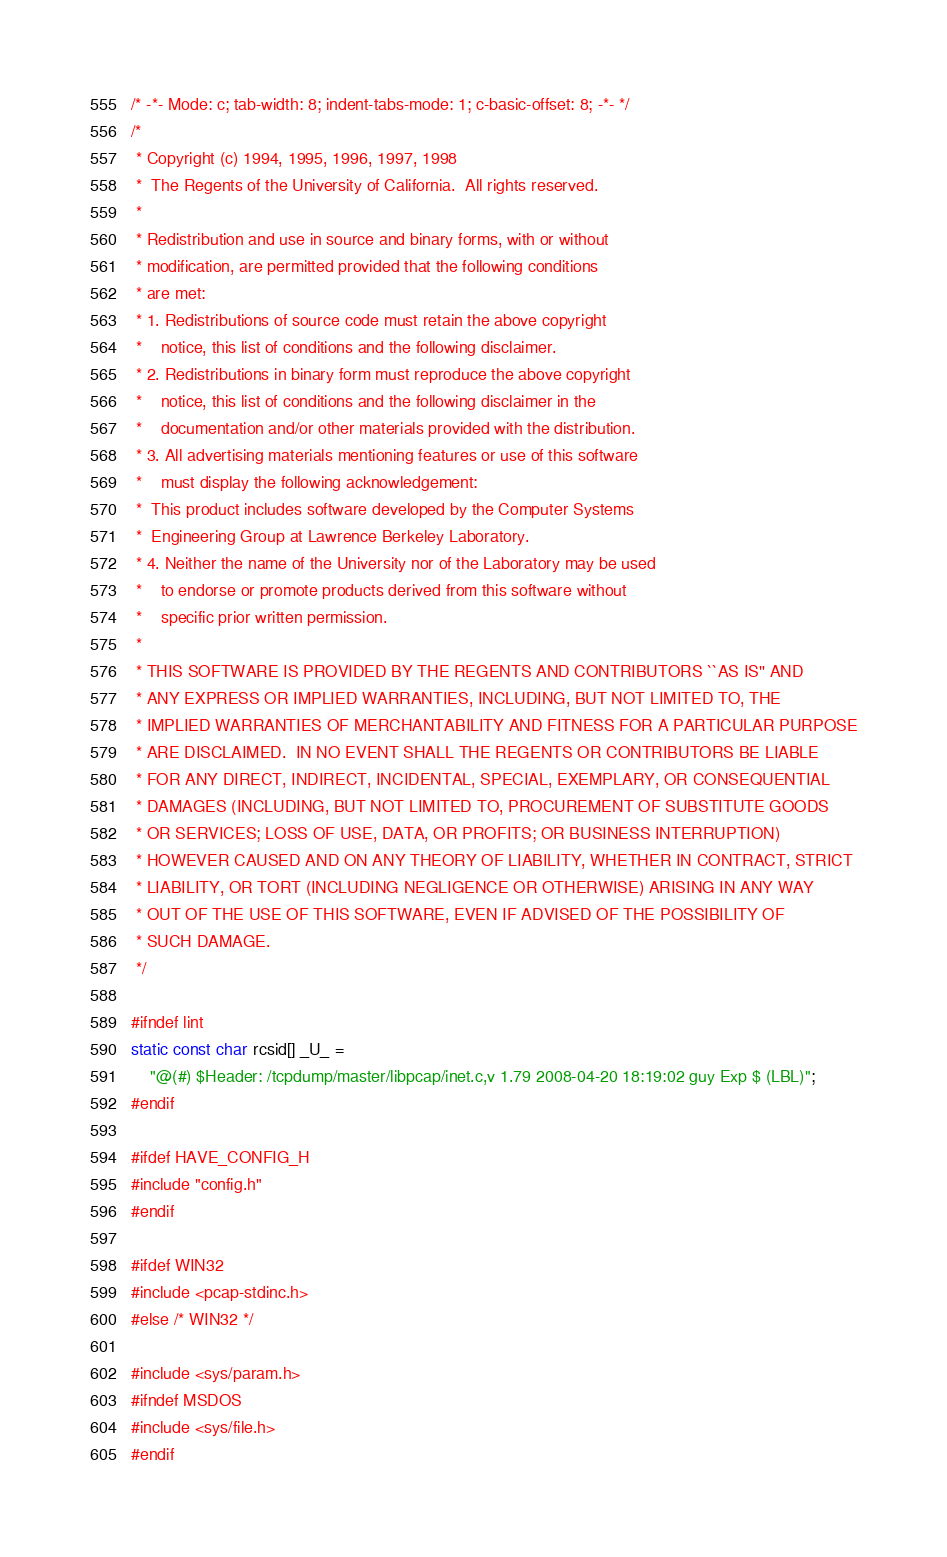Convert code to text. <code><loc_0><loc_0><loc_500><loc_500><_C_>/* -*- Mode: c; tab-width: 8; indent-tabs-mode: 1; c-basic-offset: 8; -*- */
/*
 * Copyright (c) 1994, 1995, 1996, 1997, 1998
 *	The Regents of the University of California.  All rights reserved.
 *
 * Redistribution and use in source and binary forms, with or without
 * modification, are permitted provided that the following conditions
 * are met:
 * 1. Redistributions of source code must retain the above copyright
 *    notice, this list of conditions and the following disclaimer.
 * 2. Redistributions in binary form must reproduce the above copyright
 *    notice, this list of conditions and the following disclaimer in the
 *    documentation and/or other materials provided with the distribution.
 * 3. All advertising materials mentioning features or use of this software
 *    must display the following acknowledgement:
 *	This product includes software developed by the Computer Systems
 *	Engineering Group at Lawrence Berkeley Laboratory.
 * 4. Neither the name of the University nor of the Laboratory may be used
 *    to endorse or promote products derived from this software without
 *    specific prior written permission.
 *
 * THIS SOFTWARE IS PROVIDED BY THE REGENTS AND CONTRIBUTORS ``AS IS'' AND
 * ANY EXPRESS OR IMPLIED WARRANTIES, INCLUDING, BUT NOT LIMITED TO, THE
 * IMPLIED WARRANTIES OF MERCHANTABILITY AND FITNESS FOR A PARTICULAR PURPOSE
 * ARE DISCLAIMED.  IN NO EVENT SHALL THE REGENTS OR CONTRIBUTORS BE LIABLE
 * FOR ANY DIRECT, INDIRECT, INCIDENTAL, SPECIAL, EXEMPLARY, OR CONSEQUENTIAL
 * DAMAGES (INCLUDING, BUT NOT LIMITED TO, PROCUREMENT OF SUBSTITUTE GOODS
 * OR SERVICES; LOSS OF USE, DATA, OR PROFITS; OR BUSINESS INTERRUPTION)
 * HOWEVER CAUSED AND ON ANY THEORY OF LIABILITY, WHETHER IN CONTRACT, STRICT
 * LIABILITY, OR TORT (INCLUDING NEGLIGENCE OR OTHERWISE) ARISING IN ANY WAY
 * OUT OF THE USE OF THIS SOFTWARE, EVEN IF ADVISED OF THE POSSIBILITY OF
 * SUCH DAMAGE.
 */

#ifndef lint
static const char rcsid[] _U_ =
    "@(#) $Header: /tcpdump/master/libpcap/inet.c,v 1.79 2008-04-20 18:19:02 guy Exp $ (LBL)";
#endif

#ifdef HAVE_CONFIG_H
#include "config.h"
#endif

#ifdef WIN32
#include <pcap-stdinc.h>
#else /* WIN32 */

#include <sys/param.h>
#ifndef MSDOS
#include <sys/file.h>
#endif</code> 